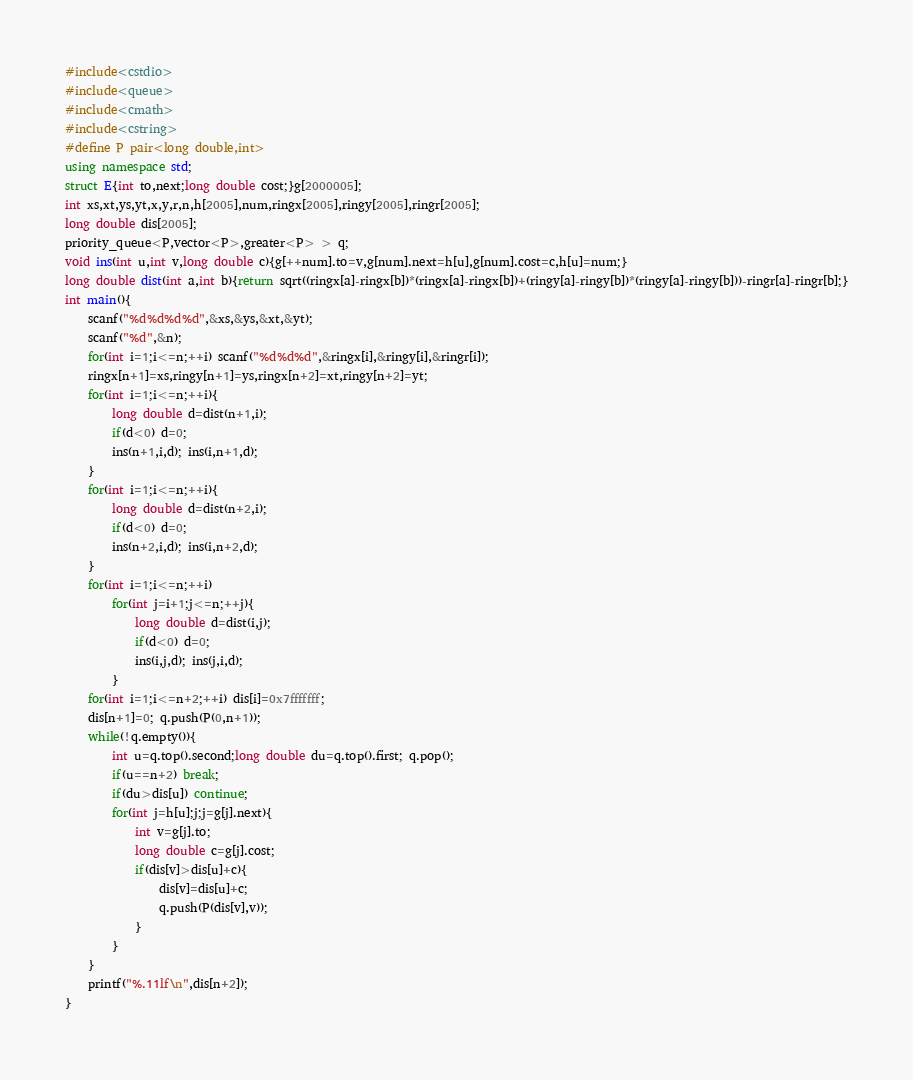Convert code to text. <code><loc_0><loc_0><loc_500><loc_500><_C++_>#include<cstdio>
#include<queue>
#include<cmath>
#include<cstring>
#define P pair<long double,int>
using namespace std;
struct E{int to,next;long double cost;}g[2000005];
int xs,xt,ys,yt,x,y,r,n,h[2005],num,ringx[2005],ringy[2005],ringr[2005];
long double dis[2005];
priority_queue<P,vector<P>,greater<P> > q;
void ins(int u,int v,long double c){g[++num].to=v,g[num].next=h[u],g[num].cost=c,h[u]=num;}
long double dist(int a,int b){return sqrt((ringx[a]-ringx[b])*(ringx[a]-ringx[b])+(ringy[a]-ringy[b])*(ringy[a]-ringy[b]))-ringr[a]-ringr[b];}
int main(){
	scanf("%d%d%d%d",&xs,&ys,&xt,&yt);
	scanf("%d",&n);
	for(int i=1;i<=n;++i) scanf("%d%d%d",&ringx[i],&ringy[i],&ringr[i]);
	ringx[n+1]=xs,ringy[n+1]=ys,ringx[n+2]=xt,ringy[n+2]=yt;
	for(int i=1;i<=n;++i){
		long double d=dist(n+1,i);
		if(d<0) d=0;
		ins(n+1,i,d); ins(i,n+1,d);
	}
	for(int i=1;i<=n;++i){
		long double d=dist(n+2,i);
		if(d<0) d=0;
		ins(n+2,i,d); ins(i,n+2,d);
	}
	for(int i=1;i<=n;++i)
		for(int j=i+1;j<=n;++j){
			long double d=dist(i,j);
			if(d<0) d=0;
			ins(i,j,d); ins(j,i,d);
		}
	for(int i=1;i<=n+2;++i) dis[i]=0x7fffffff;
    dis[n+1]=0; q.push(P(0,n+1));
    while(!q.empty()){
        int u=q.top().second;long double du=q.top().first; q.pop();
        if(u==n+2) break;
        if(du>dis[u]) continue;
        for(int j=h[u];j;j=g[j].next){
            int v=g[j].to;
			long double c=g[j].cost;
            if(dis[v]>dis[u]+c){
                dis[v]=dis[u]+c;
                q.push(P(dis[v],v));
            }
        }
    }
    printf("%.11lf\n",dis[n+2]);
}</code> 